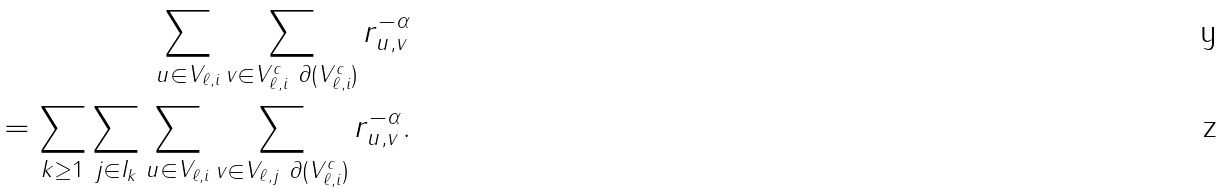Convert formula to latex. <formula><loc_0><loc_0><loc_500><loc_500>\sum _ { u \in V _ { \ell , i } } \sum _ { v \in V _ { \ell , i } ^ { c } \ \partial ( V _ { \ell , i } ^ { c } ) } r _ { u , v } ^ { - \alpha } \\ = \sum _ { k \geq 1 } \sum _ { j \in I _ { k } } \sum _ { u \in V _ { \ell , i } } \sum _ { v \in V _ { \ell , j } \ \partial ( V _ { \ell , i } ^ { c } ) } r _ { u , v } ^ { - \alpha } .</formula> 